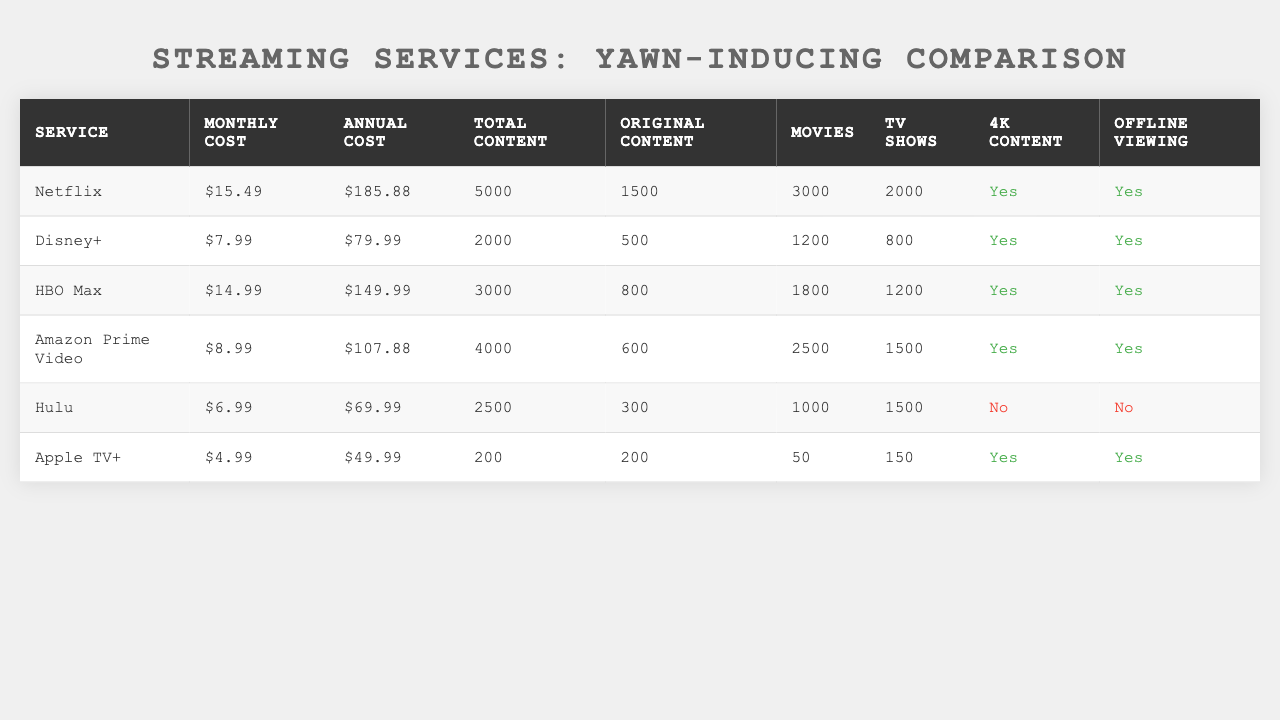What is the monthly cost of Hulu? Referring to the table under the "Monthly Cost" column for Hulu, the value listed is $6.99.
Answer: $6.99 Which streaming service has the highest total content? By comparing the "Total Content" values for each service, Netflix has the highest with 5000 total content items.
Answer: Netflix Does Apple TV+ offer offline viewing? Looking at the "Offline Viewing" column for Apple TV+, it shows "Yes," which means it does offer this feature.
Answer: Yes What is the annual cost difference between Amazon Prime Video and Disney+? The annual cost of Amazon Prime Video is $107.88 and Disney+ is $79.99. The difference is $107.88 - $79.99 = $27.89.
Answer: $27.89 What percentage of Netflix's total content is original content? Netflix has 5000 total content and 1500 original content. The percentage is (1500/5000) * 100 = 30%.
Answer: 30% Which service has more TV shows, HBO Max or Hulu? HBO Max has 1200 TV shows compared to Hulu's 1500 TV shows. Since 1500 is greater than 1200, Hulu has more.
Answer: Hulu What is the average monthly cost of the streaming services listed? The monthly costs are $15.49, $7.99, $14.99, $8.99, $6.99, and $4.99. The total is $58.44, and there are 6 services, so $58.44 / 6 = $9.74.
Answer: $9.74 Which streaming service has the lowest annual cost? By comparing the "Annual Cost" values, Apple TV+ has the lowest cost at $49.99.
Answer: Apple TV+ Is 4K content available on all services? Checking the "4K Content" column, Hulu does not offer 4K content, while others do. Therefore, it is not available on all services.
Answer: No If you combine the number of movies offered by Netflix and HBO Max, how many movies do you get? Netflix offers 3000 movies and HBO Max offers 1800 movies. The combined total is 3000 + 1800 = 4800 movies.
Answer: 4800 movies 